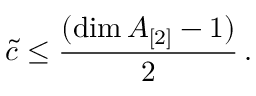<formula> <loc_0><loc_0><loc_500><loc_500>\tilde { c } \leq \frac { ( \dim A _ { [ 2 ] } - 1 ) } { 2 } \, .</formula> 